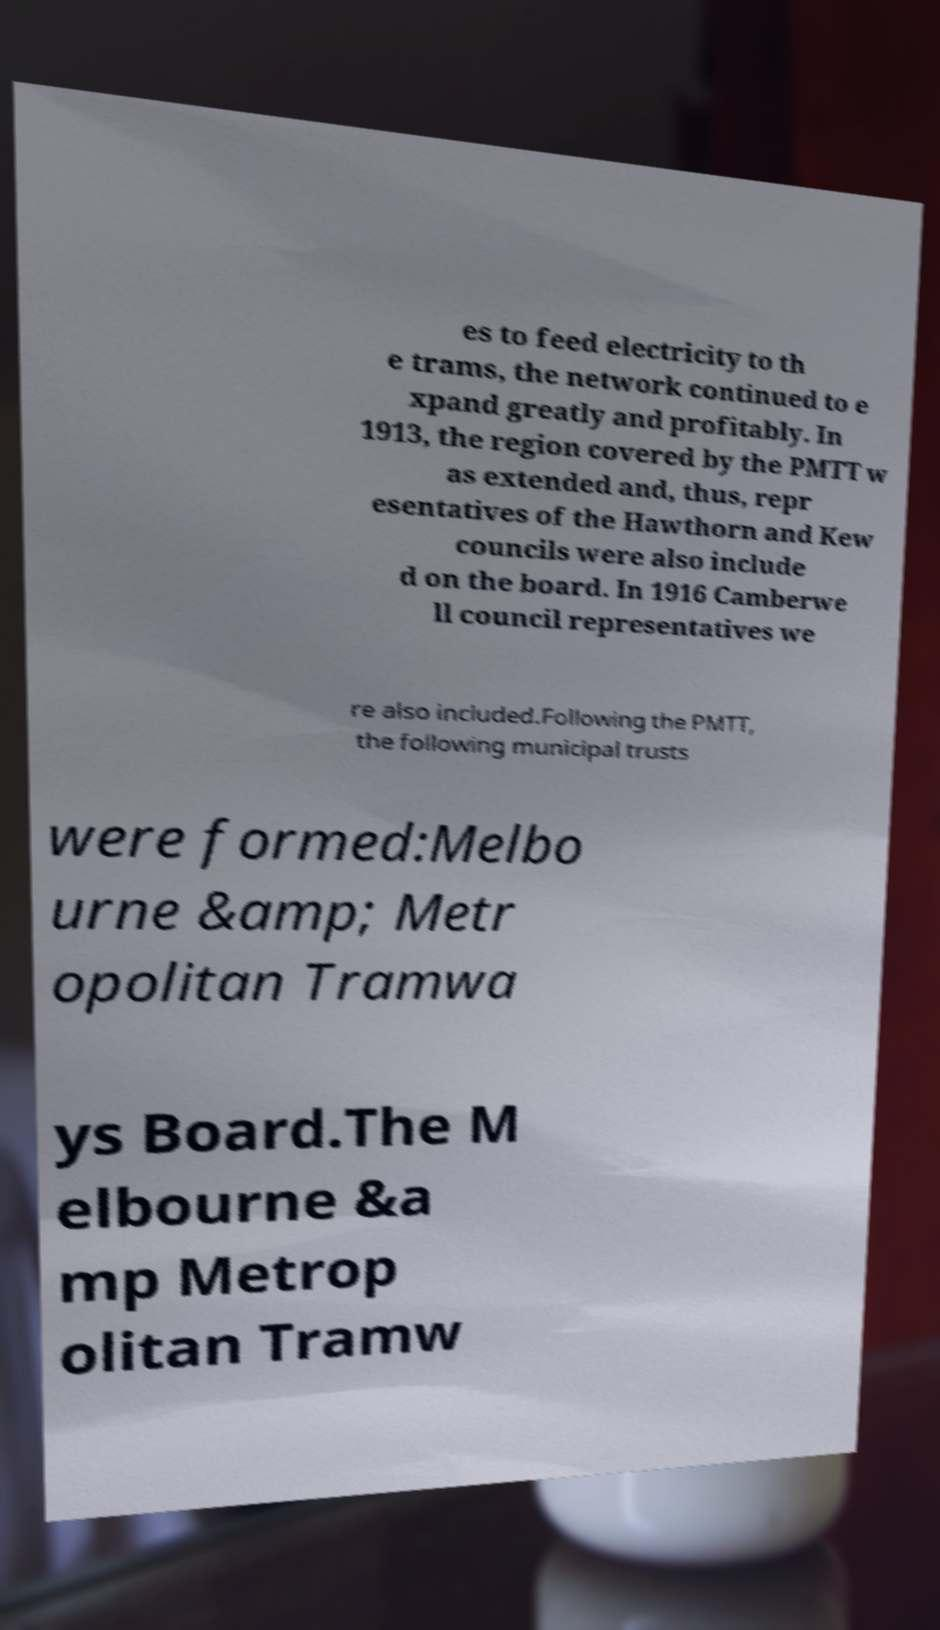Could you extract and type out the text from this image? es to feed electricity to th e trams, the network continued to e xpand greatly and profitably. In 1913, the region covered by the PMTT w as extended and, thus, repr esentatives of the Hawthorn and Kew councils were also include d on the board. In 1916 Camberwe ll council representatives we re also included.Following the PMTT, the following municipal trusts were formed:Melbo urne &amp; Metr opolitan Tramwa ys Board.The M elbourne &a mp Metrop olitan Tramw 